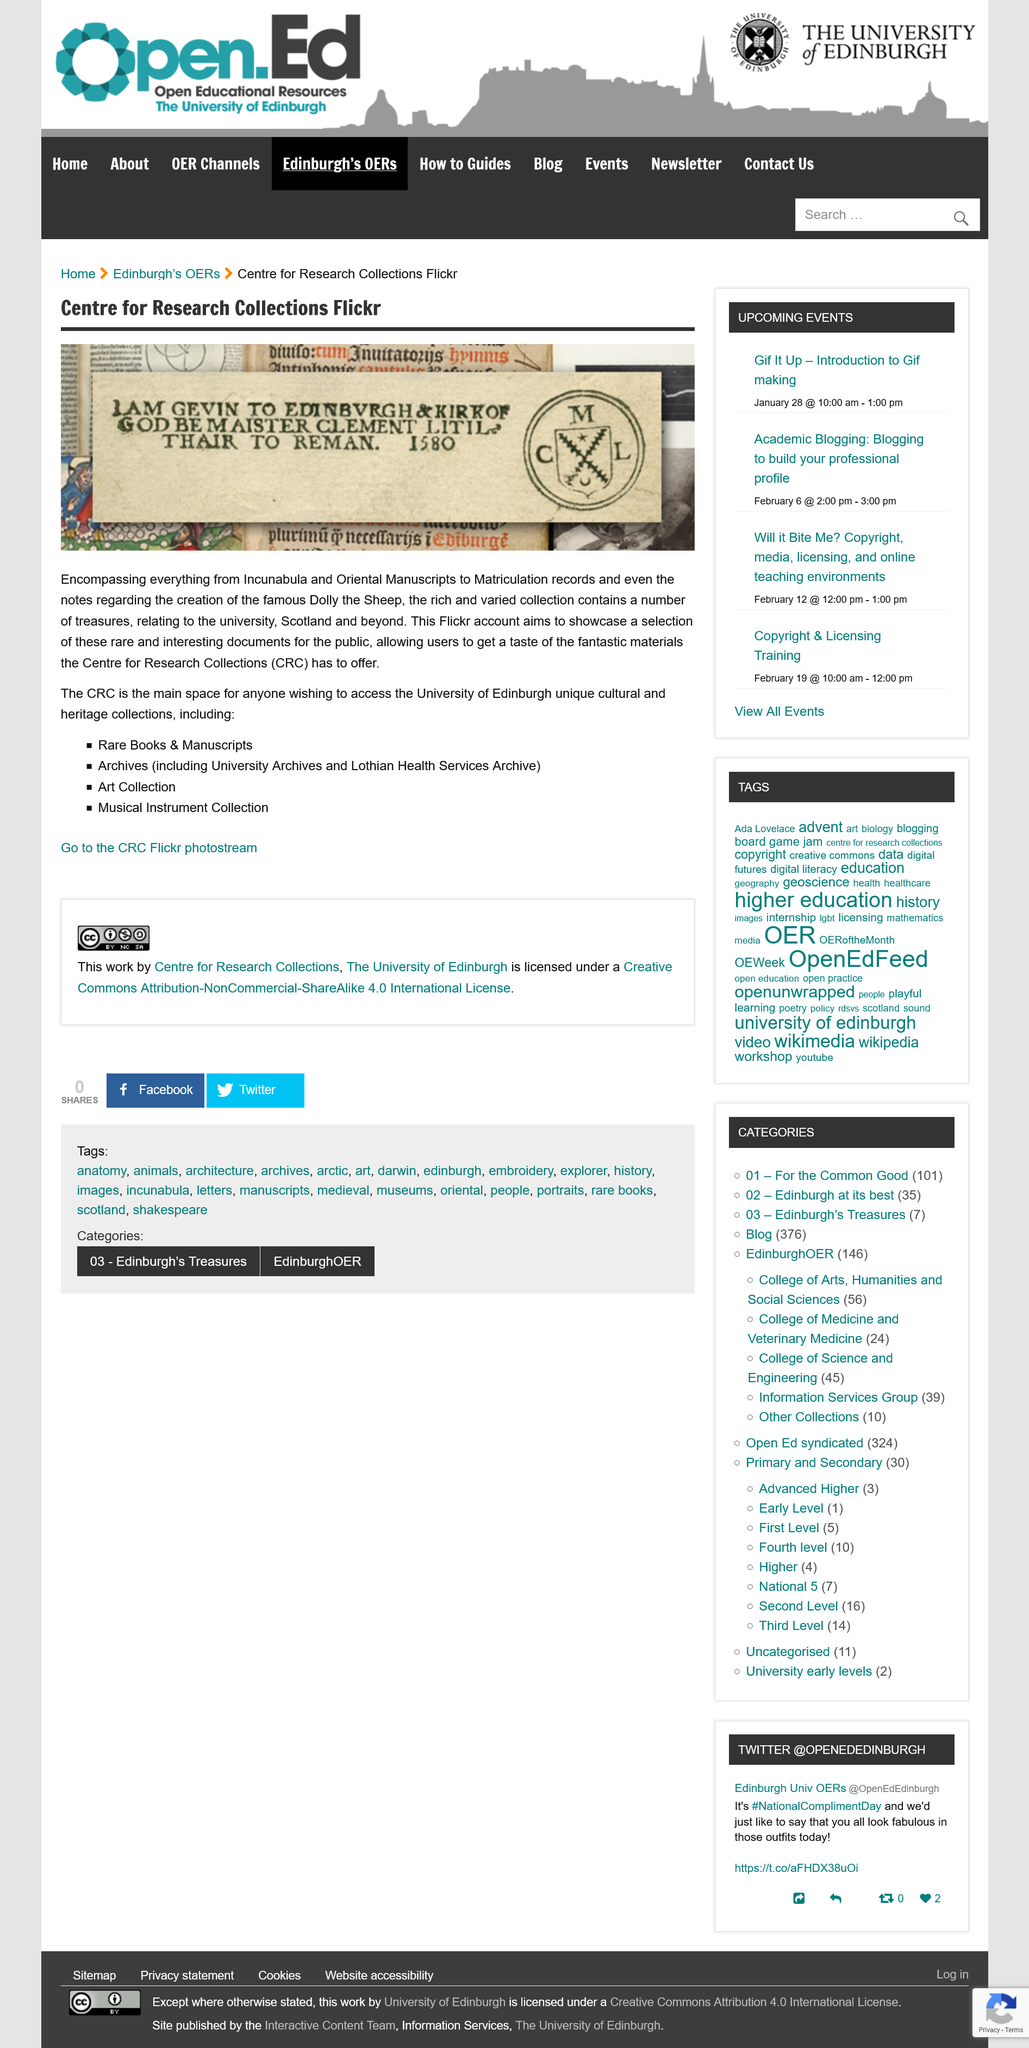Identify some key points in this picture. The Centre for Research Collections is commonly referred to as the CRC. The CRC contains a collection of rare books and manuscripts, archives, a significant art collection, and a musical instrument collection. The main space for individuals seeking to access the University of Edinburgh's diverse cultural and heritage collections is the Cultural Resources Centre (CRC). The CRC is affiliated with the University of Edinburgh. 